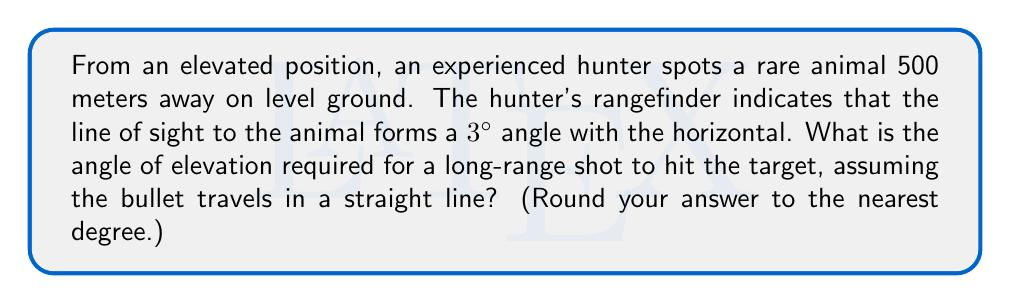Solve this math problem. Let's approach this step-by-step:

1) First, we need to visualize the scenario. We have a right triangle where:
   - The hypotenuse is the line of sight (500 m)
   - The base is the horizontal distance to the target
   - The height is the elevation difference

2) We know that the angle between the line of sight and the horizontal is 3°. Let's call the angle of elevation we're looking for $\theta$.

3) In this right triangle:
   $\cos 3° = \frac{\text{adjacent}}{\text{hypotenuse}} = \frac{\text{horizontal distance}}{500}$

4) We can calculate the horizontal distance:
   $\text{horizontal distance} = 500 \cos 3° \approx 499.13$ m

5) Now we can find the height difference using the Pythagorean theorem:
   $$\text{height}^2 = 500^2 - 499.13^2$$
   $$\text{height} = \sqrt{500^2 - 499.13^2} \approx 26.17$ m

6) Now we have a new right triangle with:
   - Base = 499.13 m
   - Height = 26.17 m

7) We can find $\theta$ using the tangent function:
   $$\tan \theta = \frac{\text{opposite}}{\text{adjacent}} = \frac{26.17}{499.13}$$

8) Solving for $\theta$:
   $$\theta = \arctan(\frac{26.17}{499.13}) \approx 3.00°$$

9) Rounding to the nearest degree, we get 3°.
Answer: $3°$ 